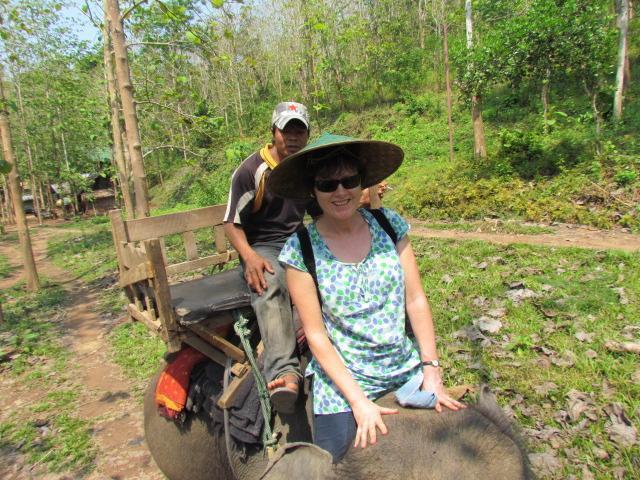Who is guiding the elephant?
Select the accurate answer and provide explanation: 'Answer: answer
Rationale: rationale.'
Options: Man, cat, woman, nobody. Answer: man.
Rationale: The guy behind the woman is giving the lady a ride on the elephant. 